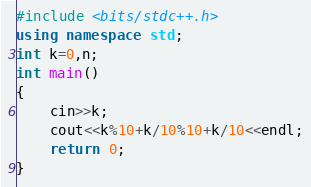<code> <loc_0><loc_0><loc_500><loc_500><_C++_>#include <bits/stdc++.h>
using namespace std;
int k=0,n;
int main()
{
    cin>>k;
    cout<<k%10+k/10%10+k/10<<endl;
    return 0;
}</code> 